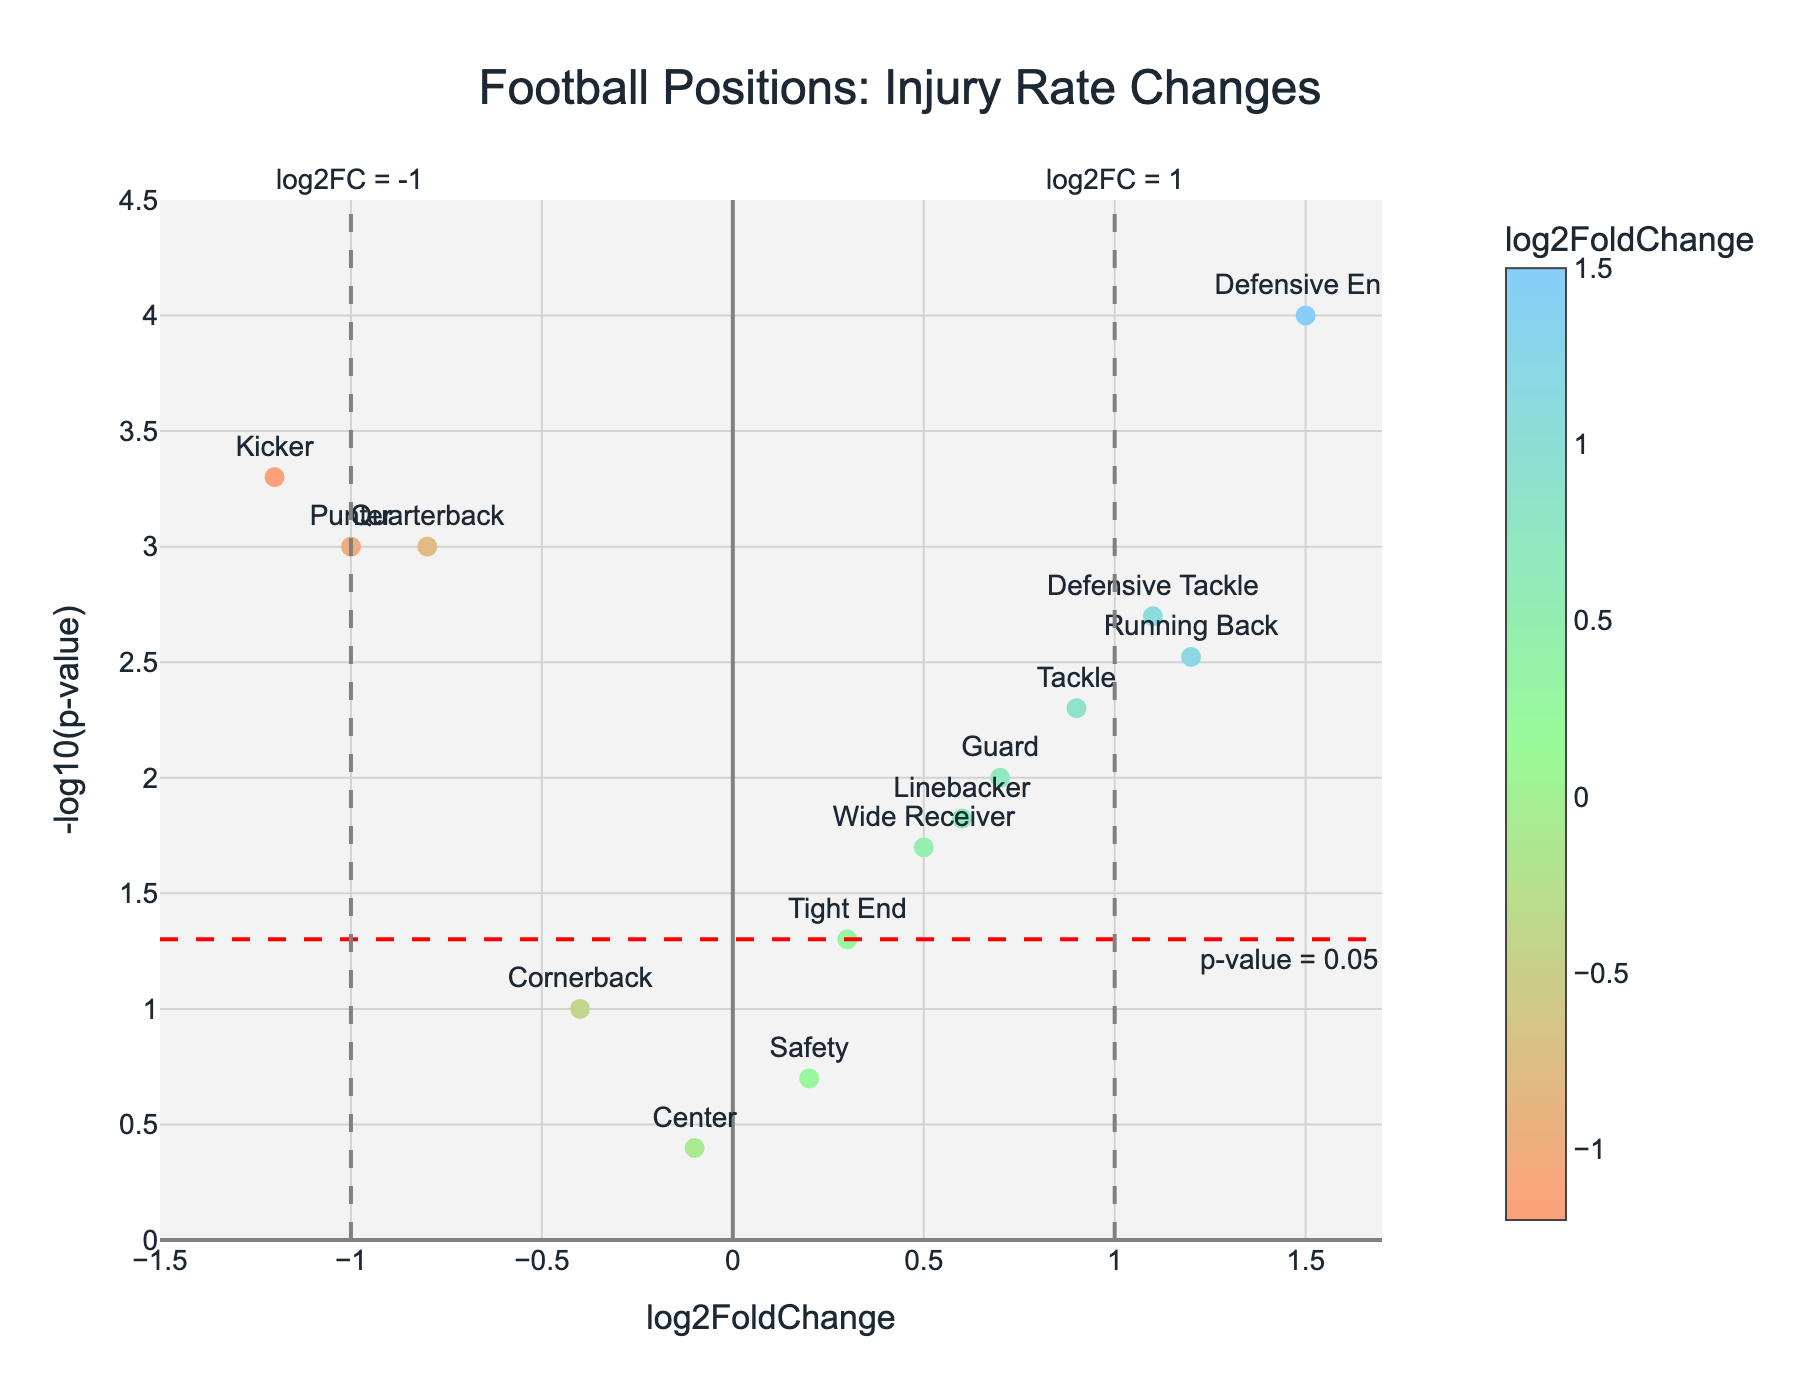What is the title of the figure? The title of a plot is usually displayed at the top of the figure. By looking at the top of this volcano plot, we can find the title which is prominently displayed.
Answer: Football Positions: Injury Rate Changes How many positions have a log2FoldChange greater than 1? To answer this, scan the x-axis (log2FoldChange) for positions where the log2FoldChange value is greater than 1. Identify each position that falls into this criteria.
Answer: Two positions Which position has the highest -log10(p-value)? To find this, look at the y-axis (-log10(p-value)) and identify the point that is the highest along this axis. The corresponding label will give the position.
Answer: Defensive End What does the red dashed horizontal line represent? In volcano plots, a horizontal line usually represents a specific p-value threshold. Here, the red dashed line is annotated, showing it corresponds to a p-value threshold of 0.05.
Answer: p-value = 0.05 Which positions have a log2FoldChange less than -1? To address this, inspect the x-axis (log2FoldChange) for positions where the value is less than -1. Then check the labels of these points to identify the positions.
Answer: Kicker, Punter What is the log2FoldChange and p-value for Running Back? Find the point corresponding to Running Back by its text label, then read off its position along the x-axis (log2FoldChange) and the hover text or calculate p-value from -log10(p-value).
Answer: 1.2, 0.003 Compare the injury rate change of Running Backs with Quarterbacks. Which position shows a higher log2FoldChange? Look at the x-axis values for both Running Back and Quarterback. Running Back has a log2FoldChange of 1.2, while Quarterback has -0.8, thus Running Back is higher.
Answer: Running Back How many positions are statistically significant based on the p-value threshold of 0.05? Identify the points that have a -log10(p-value) higher than -log10(0.05), indicating a p-value less than 0.05. Count these points.
Answer: Nine positions Which position has the lowest injury rate change? To find the position with the lowest log2FoldChange value, look at the leftmost point on the x-axis.
Answer: Kicker 